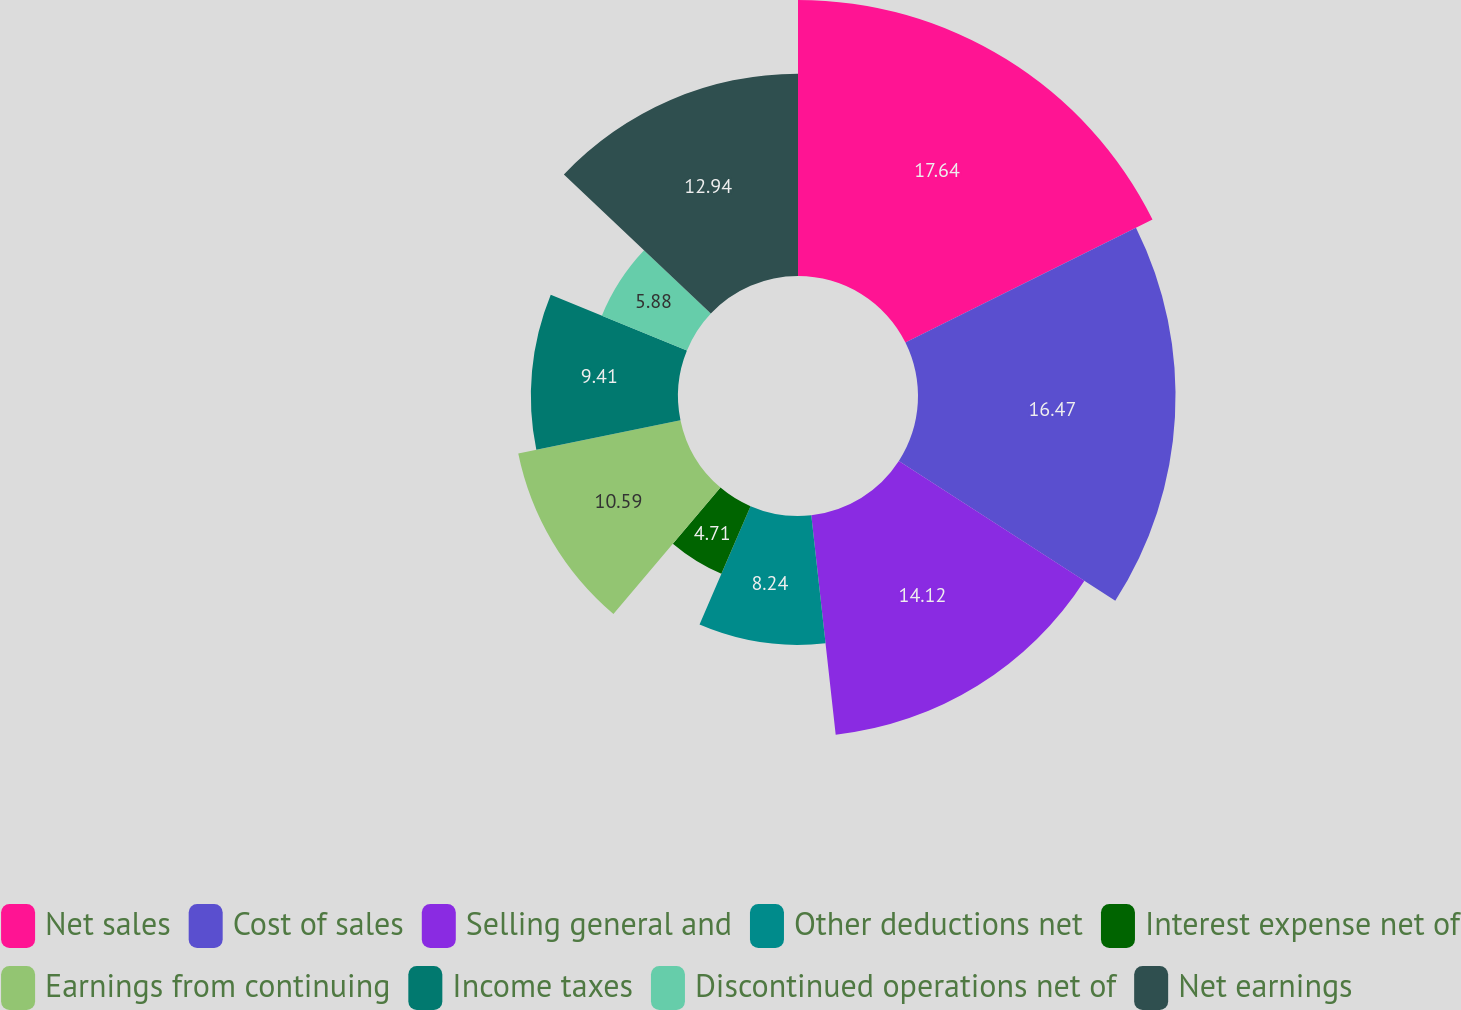Convert chart. <chart><loc_0><loc_0><loc_500><loc_500><pie_chart><fcel>Net sales<fcel>Cost of sales<fcel>Selling general and<fcel>Other deductions net<fcel>Interest expense net of<fcel>Earnings from continuing<fcel>Income taxes<fcel>Discontinued operations net of<fcel>Net earnings<nl><fcel>17.65%<fcel>16.47%<fcel>14.12%<fcel>8.24%<fcel>4.71%<fcel>10.59%<fcel>9.41%<fcel>5.88%<fcel>12.94%<nl></chart> 